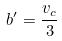<formula> <loc_0><loc_0><loc_500><loc_500>b ^ { \prime } = \frac { v _ { c } } { 3 }</formula> 